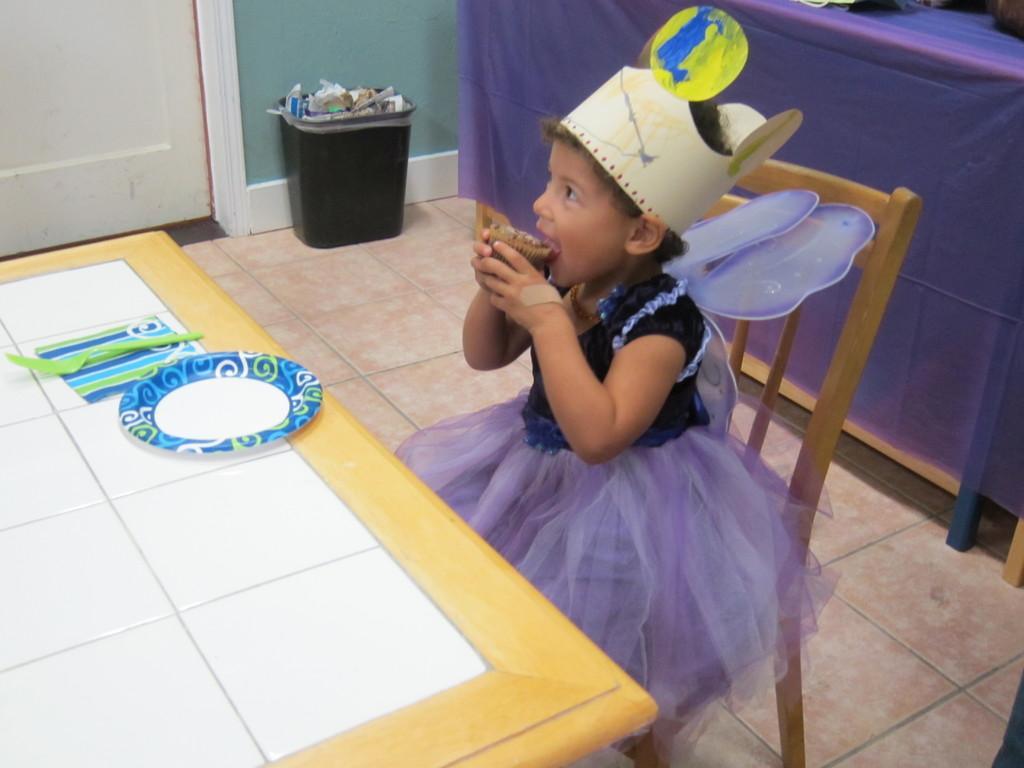Describe this image in one or two sentences. In this picture there is a girl who is sitting on the chair. she is eating cake. There is a plate, spoon , napkin on the table. There is a dustbin. There is a cloth at the background. 